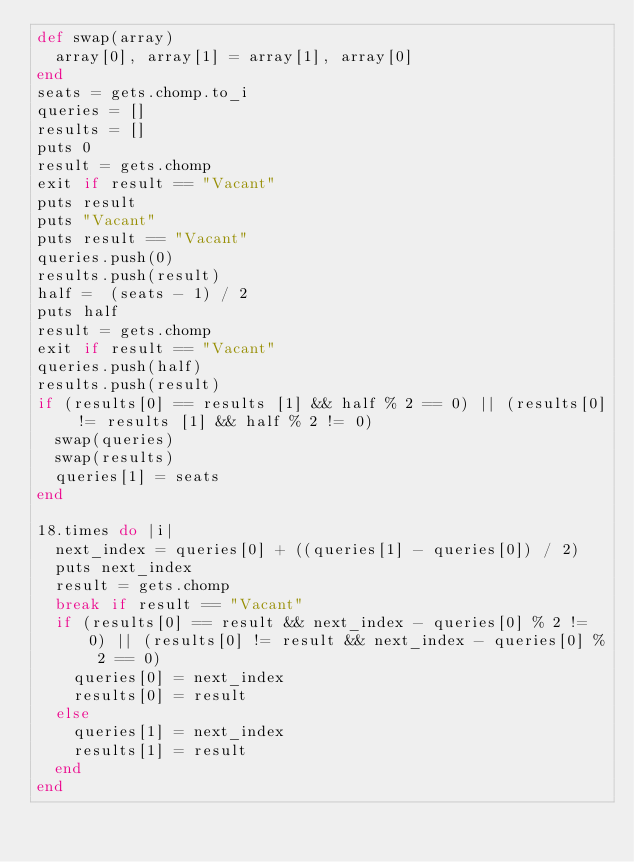Convert code to text. <code><loc_0><loc_0><loc_500><loc_500><_Ruby_>def swap(array)
  array[0], array[1] = array[1], array[0]
end
seats = gets.chomp.to_i
queries = []
results = []
puts 0
result = gets.chomp
exit if result == "Vacant"
puts result
puts "Vacant"
puts result == "Vacant"
queries.push(0)
results.push(result)
half =  (seats - 1) / 2
puts half
result = gets.chomp
exit if result == "Vacant"
queries.push(half)
results.push(result)
if (results[0] == results [1] && half % 2 == 0) || (results[0] != results [1] && half % 2 != 0)
  swap(queries)
  swap(results)
  queries[1] = seats
end

18.times do |i|
  next_index = queries[0] + ((queries[1] - queries[0]) / 2)
  puts next_index
  result = gets.chomp
  break if result == "Vacant"
  if (results[0] == result && next_index - queries[0] % 2 != 0) || (results[0] != result && next_index - queries[0] % 2 == 0)
    queries[0] = next_index
    results[0] = result
  else
    queries[1] = next_index
    results[1] = result
  end
end
</code> 